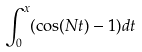Convert formula to latex. <formula><loc_0><loc_0><loc_500><loc_500>\int _ { 0 } ^ { x } ( \cos ( N t ) - 1 ) d t</formula> 